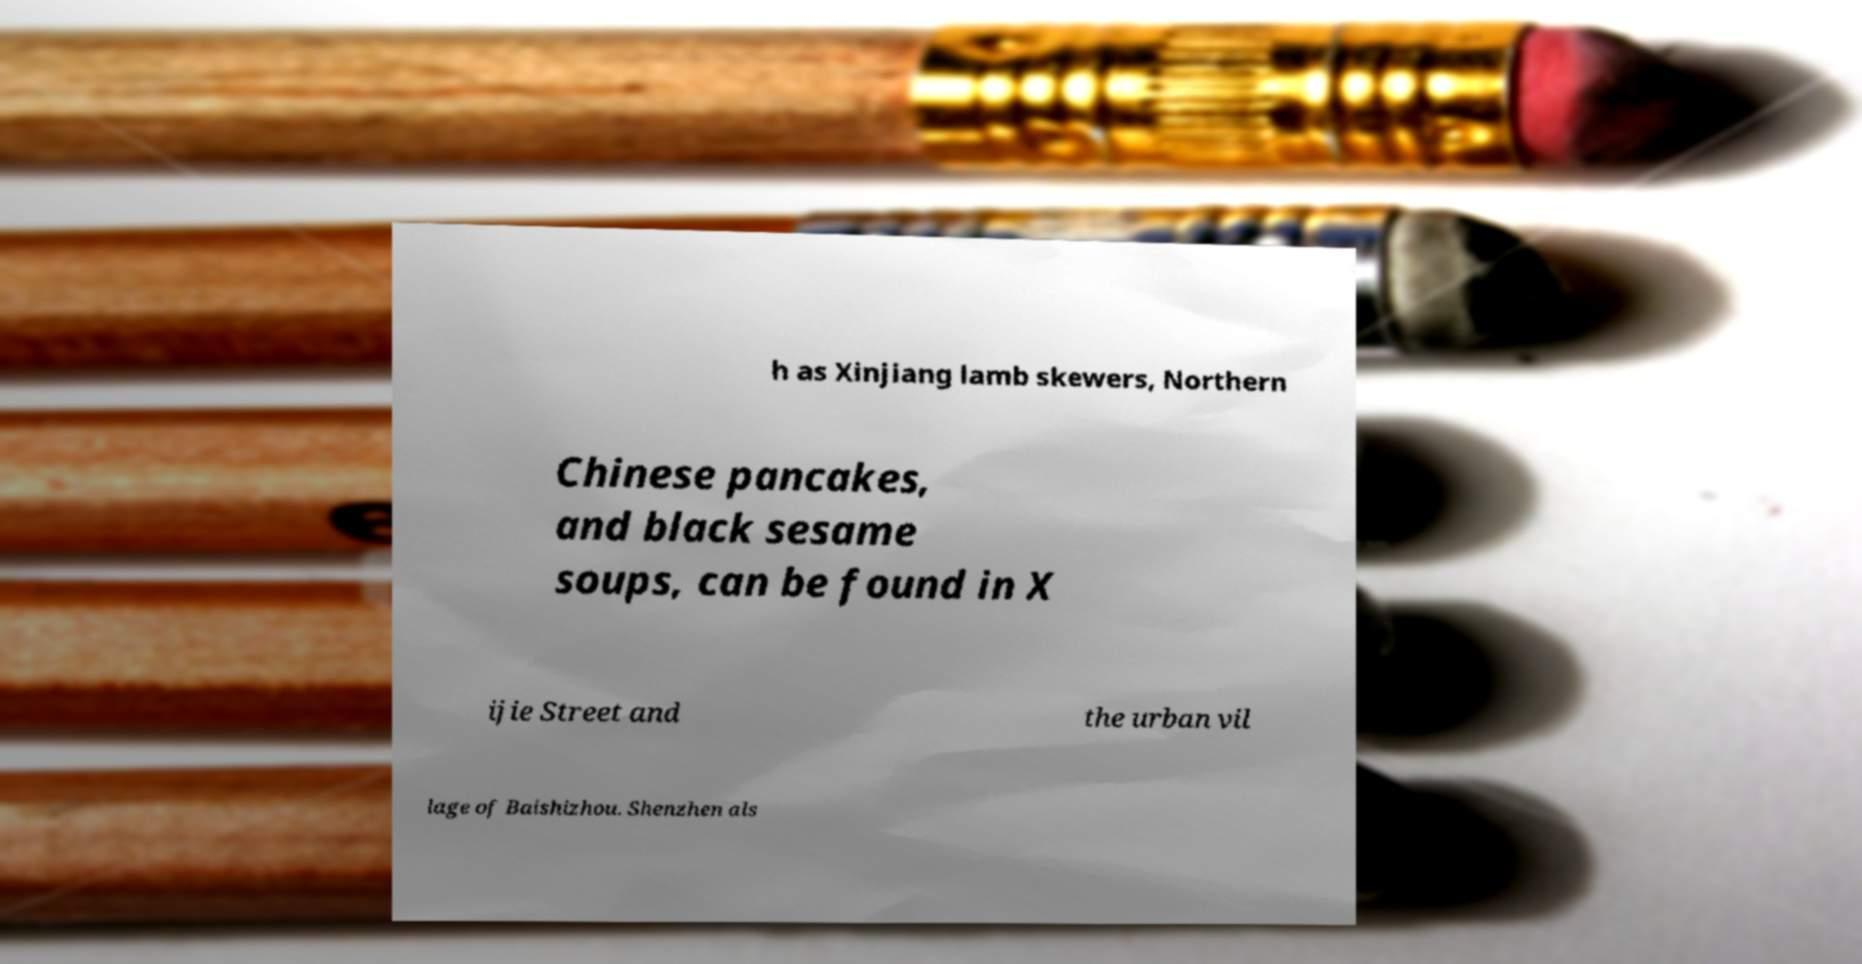Can you read and provide the text displayed in the image?This photo seems to have some interesting text. Can you extract and type it out for me? h as Xinjiang lamb skewers, Northern Chinese pancakes, and black sesame soups, can be found in X ijie Street and the urban vil lage of Baishizhou. Shenzhen als 